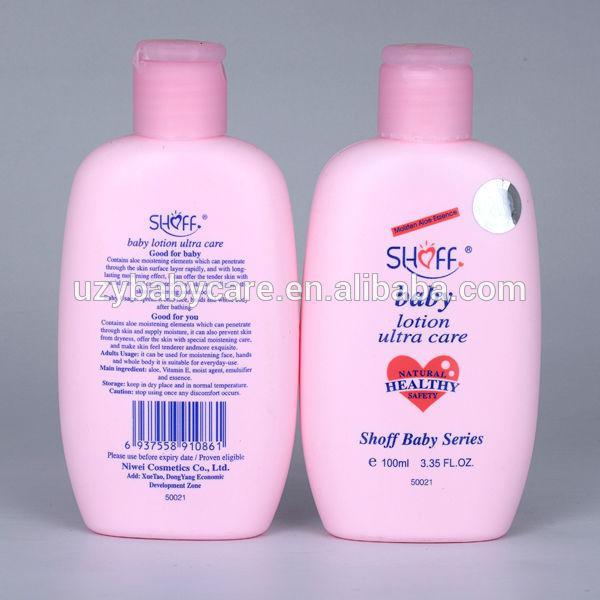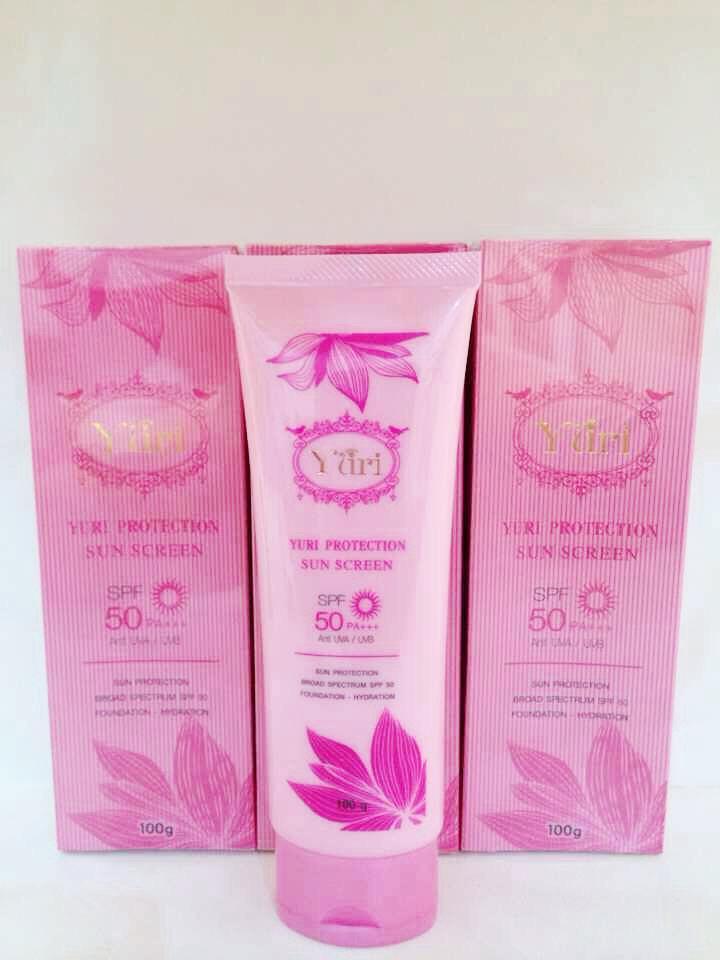The first image is the image on the left, the second image is the image on the right. For the images displayed, is the sentence "One image has a single tube of beauty cream standing on end." factually correct? Answer yes or no. Yes. The first image is the image on the left, the second image is the image on the right. Assess this claim about the two images: "There are not more than two different products and they are all made by Ponds.". Correct or not? Answer yes or no. No. 